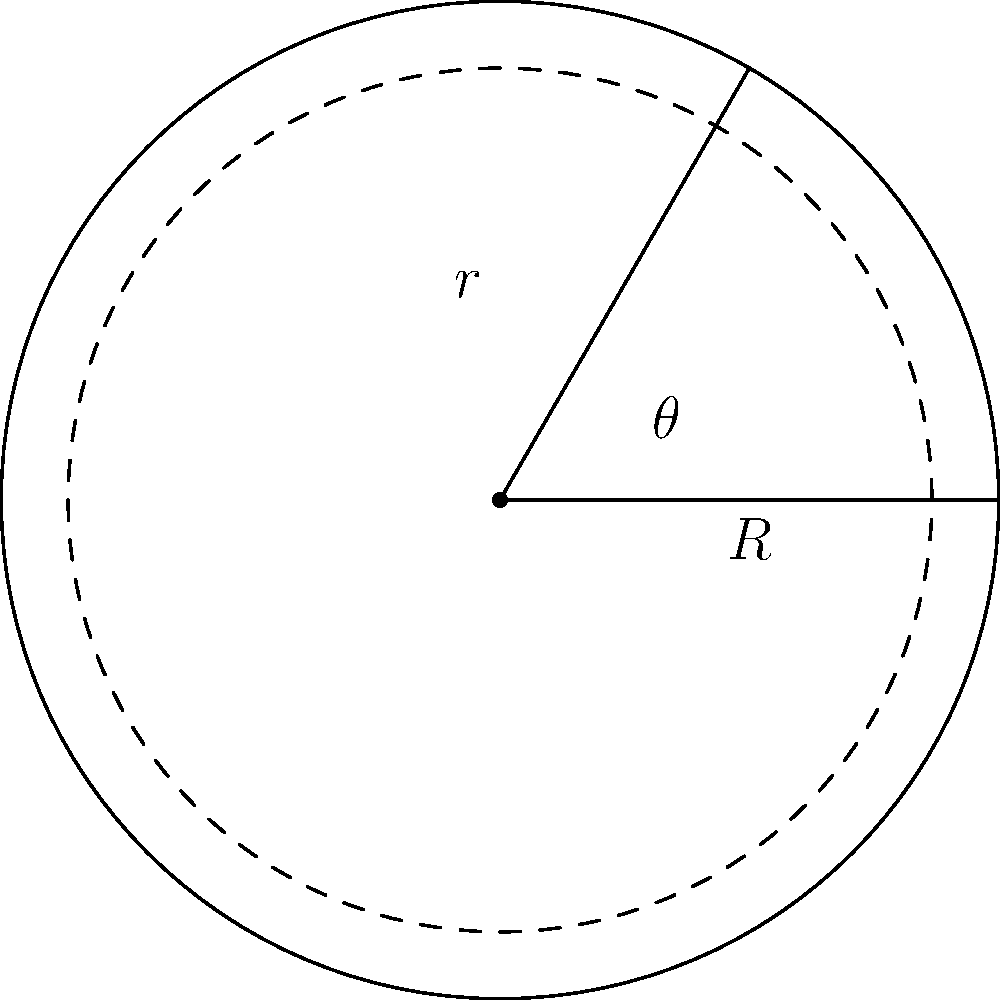A car's turning circle has a radius of 50 meters, and its wheels can turn up to 60 degrees. What is the radius of the smallest circular zone in which the car can make a complete turn? To solve this problem, we need to use trigonometry:

1. Let $R$ be the radius of the car's turning circle (50 meters).
2. Let $\theta$ be the maximum turning angle of the wheels (60 degrees).
3. Let $r$ be the radius of the smallest circular zone we're looking for.

We can see that these form a right-angled triangle, where:
- The hypotenuse is $R$
- One of the angles is $\theta$
- The opposite side to this angle is $r$

Using the sine function:

$$\sin(\theta) = \frac{r}{R}$$

Rearranging this:

$$r = R \cdot \sin(\theta)$$

Plugging in our values:

$$r = 50 \cdot \sin(60°)$$

$$r = 50 \cdot \frac{\sqrt{3}}{2}$$

$$r = 25\sqrt{3} \approx 43.3$$

Therefore, the radius of the smallest circular zone in which the car can make a complete turn is approximately 43.3 meters.
Answer: $25\sqrt{3}$ meters 